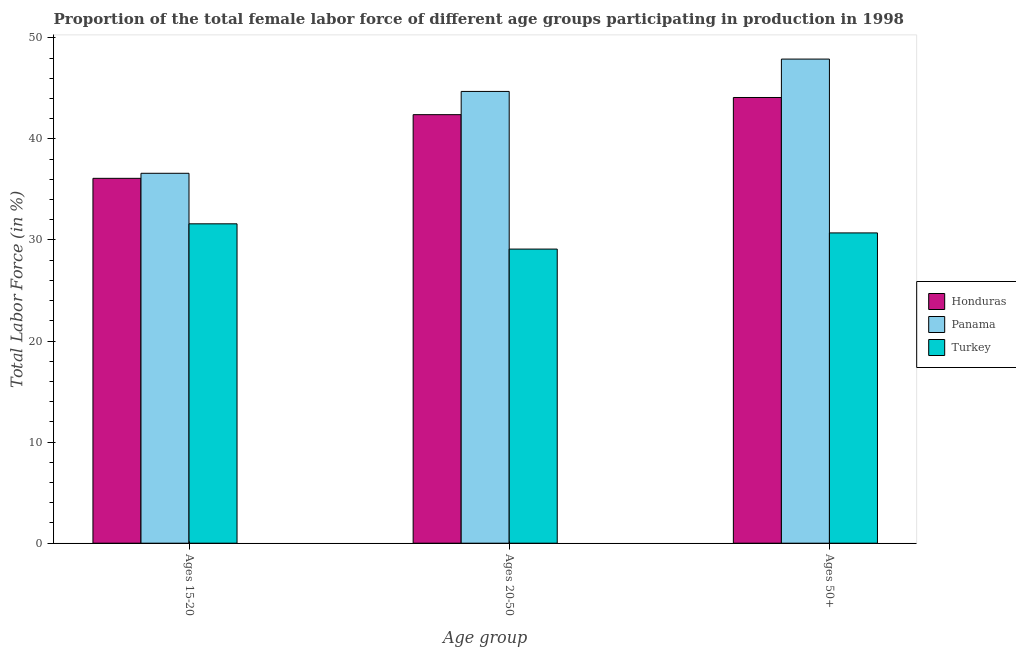Are the number of bars per tick equal to the number of legend labels?
Provide a short and direct response. Yes. Are the number of bars on each tick of the X-axis equal?
Your response must be concise. Yes. How many bars are there on the 2nd tick from the left?
Your answer should be compact. 3. How many bars are there on the 1st tick from the right?
Provide a succinct answer. 3. What is the label of the 2nd group of bars from the left?
Ensure brevity in your answer.  Ages 20-50. What is the percentage of female labor force within the age group 15-20 in Turkey?
Make the answer very short. 31.6. Across all countries, what is the maximum percentage of female labor force above age 50?
Give a very brief answer. 47.9. Across all countries, what is the minimum percentage of female labor force above age 50?
Make the answer very short. 30.7. In which country was the percentage of female labor force within the age group 20-50 maximum?
Provide a short and direct response. Panama. In which country was the percentage of female labor force above age 50 minimum?
Ensure brevity in your answer.  Turkey. What is the total percentage of female labor force within the age group 20-50 in the graph?
Make the answer very short. 116.2. What is the difference between the percentage of female labor force within the age group 20-50 in Panama and that in Turkey?
Offer a very short reply. 15.6. What is the difference between the percentage of female labor force above age 50 in Panama and the percentage of female labor force within the age group 15-20 in Honduras?
Your response must be concise. 11.8. What is the average percentage of female labor force above age 50 per country?
Offer a very short reply. 40.9. What is the difference between the percentage of female labor force within the age group 15-20 and percentage of female labor force within the age group 20-50 in Panama?
Give a very brief answer. -8.1. What is the ratio of the percentage of female labor force above age 50 in Panama to that in Turkey?
Provide a short and direct response. 1.56. Is the difference between the percentage of female labor force within the age group 15-20 in Turkey and Honduras greater than the difference between the percentage of female labor force within the age group 20-50 in Turkey and Honduras?
Offer a terse response. Yes. What is the difference between the highest and the second highest percentage of female labor force within the age group 20-50?
Make the answer very short. 2.3. What is the difference between the highest and the lowest percentage of female labor force within the age group 20-50?
Your answer should be very brief. 15.6. What does the 1st bar from the left in Ages 20-50 represents?
Provide a short and direct response. Honduras. What does the 3rd bar from the right in Ages 50+ represents?
Keep it short and to the point. Honduras. Are all the bars in the graph horizontal?
Your answer should be compact. No. How many countries are there in the graph?
Provide a succinct answer. 3. Are the values on the major ticks of Y-axis written in scientific E-notation?
Make the answer very short. No. Does the graph contain any zero values?
Keep it short and to the point. No. Where does the legend appear in the graph?
Offer a very short reply. Center right. How are the legend labels stacked?
Make the answer very short. Vertical. What is the title of the graph?
Your response must be concise. Proportion of the total female labor force of different age groups participating in production in 1998. What is the label or title of the X-axis?
Keep it short and to the point. Age group. What is the label or title of the Y-axis?
Give a very brief answer. Total Labor Force (in %). What is the Total Labor Force (in %) of Honduras in Ages 15-20?
Keep it short and to the point. 36.1. What is the Total Labor Force (in %) of Panama in Ages 15-20?
Your answer should be very brief. 36.6. What is the Total Labor Force (in %) in Turkey in Ages 15-20?
Ensure brevity in your answer.  31.6. What is the Total Labor Force (in %) in Honduras in Ages 20-50?
Ensure brevity in your answer.  42.4. What is the Total Labor Force (in %) of Panama in Ages 20-50?
Keep it short and to the point. 44.7. What is the Total Labor Force (in %) in Turkey in Ages 20-50?
Give a very brief answer. 29.1. What is the Total Labor Force (in %) in Honduras in Ages 50+?
Give a very brief answer. 44.1. What is the Total Labor Force (in %) in Panama in Ages 50+?
Your answer should be very brief. 47.9. What is the Total Labor Force (in %) in Turkey in Ages 50+?
Your response must be concise. 30.7. Across all Age group, what is the maximum Total Labor Force (in %) of Honduras?
Offer a very short reply. 44.1. Across all Age group, what is the maximum Total Labor Force (in %) of Panama?
Provide a succinct answer. 47.9. Across all Age group, what is the maximum Total Labor Force (in %) in Turkey?
Ensure brevity in your answer.  31.6. Across all Age group, what is the minimum Total Labor Force (in %) in Honduras?
Keep it short and to the point. 36.1. Across all Age group, what is the minimum Total Labor Force (in %) of Panama?
Your answer should be very brief. 36.6. Across all Age group, what is the minimum Total Labor Force (in %) of Turkey?
Provide a succinct answer. 29.1. What is the total Total Labor Force (in %) in Honduras in the graph?
Offer a terse response. 122.6. What is the total Total Labor Force (in %) of Panama in the graph?
Provide a short and direct response. 129.2. What is the total Total Labor Force (in %) in Turkey in the graph?
Your response must be concise. 91.4. What is the difference between the Total Labor Force (in %) in Honduras in Ages 15-20 and that in Ages 50+?
Provide a succinct answer. -8. What is the difference between the Total Labor Force (in %) in Turkey in Ages 15-20 and that in Ages 50+?
Keep it short and to the point. 0.9. What is the difference between the Total Labor Force (in %) of Panama in Ages 20-50 and that in Ages 50+?
Provide a succinct answer. -3.2. What is the difference between the Total Labor Force (in %) in Panama in Ages 15-20 and the Total Labor Force (in %) in Turkey in Ages 20-50?
Provide a short and direct response. 7.5. What is the difference between the Total Labor Force (in %) of Panama in Ages 15-20 and the Total Labor Force (in %) of Turkey in Ages 50+?
Keep it short and to the point. 5.9. What is the difference between the Total Labor Force (in %) of Honduras in Ages 20-50 and the Total Labor Force (in %) of Turkey in Ages 50+?
Give a very brief answer. 11.7. What is the difference between the Total Labor Force (in %) in Panama in Ages 20-50 and the Total Labor Force (in %) in Turkey in Ages 50+?
Keep it short and to the point. 14. What is the average Total Labor Force (in %) in Honduras per Age group?
Your response must be concise. 40.87. What is the average Total Labor Force (in %) of Panama per Age group?
Give a very brief answer. 43.07. What is the average Total Labor Force (in %) of Turkey per Age group?
Ensure brevity in your answer.  30.47. What is the difference between the Total Labor Force (in %) in Honduras and Total Labor Force (in %) in Panama in Ages 15-20?
Ensure brevity in your answer.  -0.5. What is the difference between the Total Labor Force (in %) in Honduras and Total Labor Force (in %) in Turkey in Ages 15-20?
Your answer should be very brief. 4.5. What is the difference between the Total Labor Force (in %) in Panama and Total Labor Force (in %) in Turkey in Ages 20-50?
Make the answer very short. 15.6. What is the difference between the Total Labor Force (in %) in Honduras and Total Labor Force (in %) in Panama in Ages 50+?
Your answer should be compact. -3.8. What is the difference between the Total Labor Force (in %) in Honduras and Total Labor Force (in %) in Turkey in Ages 50+?
Your answer should be compact. 13.4. What is the ratio of the Total Labor Force (in %) of Honduras in Ages 15-20 to that in Ages 20-50?
Your response must be concise. 0.85. What is the ratio of the Total Labor Force (in %) of Panama in Ages 15-20 to that in Ages 20-50?
Your answer should be very brief. 0.82. What is the ratio of the Total Labor Force (in %) in Turkey in Ages 15-20 to that in Ages 20-50?
Your answer should be very brief. 1.09. What is the ratio of the Total Labor Force (in %) in Honduras in Ages 15-20 to that in Ages 50+?
Give a very brief answer. 0.82. What is the ratio of the Total Labor Force (in %) in Panama in Ages 15-20 to that in Ages 50+?
Ensure brevity in your answer.  0.76. What is the ratio of the Total Labor Force (in %) in Turkey in Ages 15-20 to that in Ages 50+?
Give a very brief answer. 1.03. What is the ratio of the Total Labor Force (in %) in Honduras in Ages 20-50 to that in Ages 50+?
Give a very brief answer. 0.96. What is the ratio of the Total Labor Force (in %) of Panama in Ages 20-50 to that in Ages 50+?
Your response must be concise. 0.93. What is the ratio of the Total Labor Force (in %) of Turkey in Ages 20-50 to that in Ages 50+?
Ensure brevity in your answer.  0.95. What is the difference between the highest and the second highest Total Labor Force (in %) in Panama?
Provide a short and direct response. 3.2. What is the difference between the highest and the second highest Total Labor Force (in %) in Turkey?
Offer a very short reply. 0.9. What is the difference between the highest and the lowest Total Labor Force (in %) of Honduras?
Offer a very short reply. 8. What is the difference between the highest and the lowest Total Labor Force (in %) of Panama?
Your answer should be very brief. 11.3. What is the difference between the highest and the lowest Total Labor Force (in %) of Turkey?
Provide a short and direct response. 2.5. 